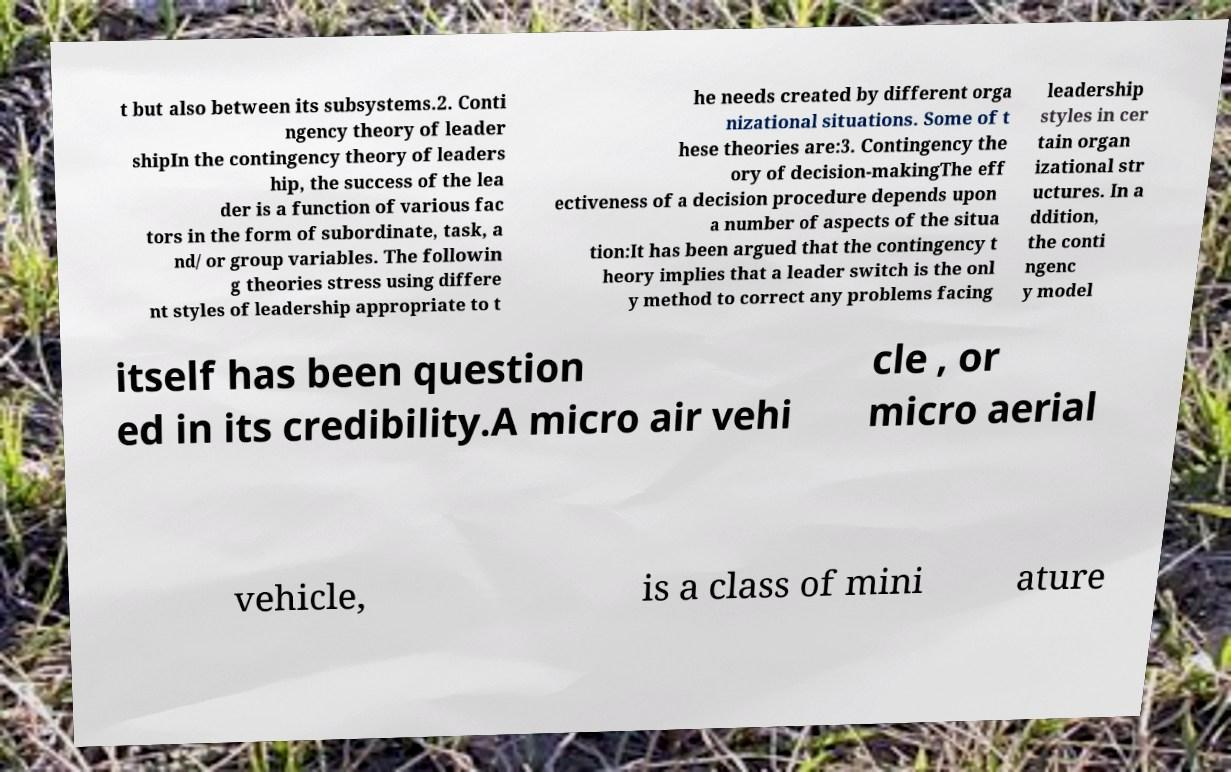There's text embedded in this image that I need extracted. Can you transcribe it verbatim? t but also between its subsystems.2. Conti ngency theory of leader shipIn the contingency theory of leaders hip, the success of the lea der is a function of various fac tors in the form of subordinate, task, a nd/ or group variables. The followin g theories stress using differe nt styles of leadership appropriate to t he needs created by different orga nizational situations. Some of t hese theories are:3. Contingency the ory of decision-makingThe eff ectiveness of a decision procedure depends upon a number of aspects of the situa tion:It has been argued that the contingency t heory implies that a leader switch is the onl y method to correct any problems facing leadership styles in cer tain organ izational str uctures. In a ddition, the conti ngenc y model itself has been question ed in its credibility.A micro air vehi cle , or micro aerial vehicle, is a class of mini ature 